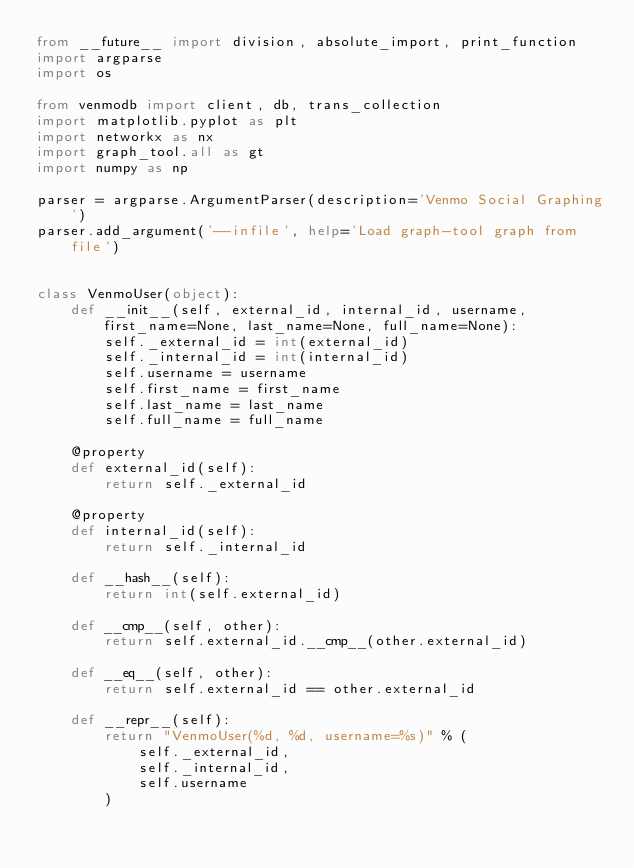Convert code to text. <code><loc_0><loc_0><loc_500><loc_500><_Python_>from __future__ import division, absolute_import, print_function
import argparse
import os

from venmodb import client, db, trans_collection
import matplotlib.pyplot as plt
import networkx as nx
import graph_tool.all as gt
import numpy as np

parser = argparse.ArgumentParser(description='Venmo Social Graphing')
parser.add_argument('--infile', help='Load graph-tool graph from file')


class VenmoUser(object):
    def __init__(self, external_id, internal_id, username, first_name=None, last_name=None, full_name=None):
        self._external_id = int(external_id)
        self._internal_id = int(internal_id)
        self.username = username
        self.first_name = first_name
        self.last_name = last_name
        self.full_name = full_name

    @property
    def external_id(self):
        return self._external_id

    @property
    def internal_id(self):
        return self._internal_id

    def __hash__(self):
        return int(self.external_id)

    def __cmp__(self, other):
        return self.external_id.__cmp__(other.external_id)

    def __eq__(self, other):
        return self.external_id == other.external_id

    def __repr__(self):
        return "VenmoUser(%d, %d, username=%s)" % (
            self._external_id,
            self._internal_id,
            self.username
        )
</code> 